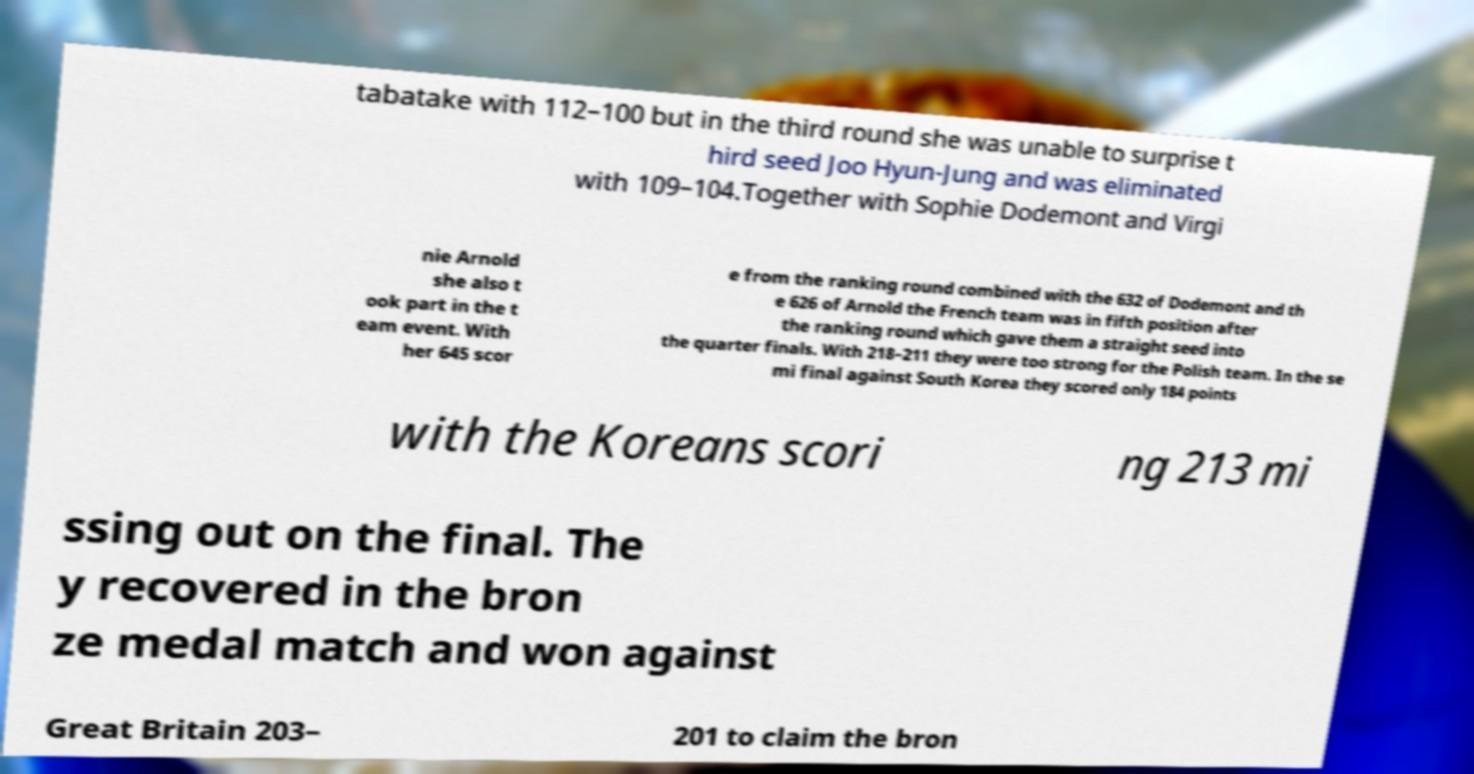Could you extract and type out the text from this image? tabatake with 112–100 but in the third round she was unable to surprise t hird seed Joo Hyun-Jung and was eliminated with 109–104.Together with Sophie Dodemont and Virgi nie Arnold she also t ook part in the t eam event. With her 645 scor e from the ranking round combined with the 632 of Dodemont and th e 626 of Arnold the French team was in fifth position after the ranking round which gave them a straight seed into the quarter finals. With 218–211 they were too strong for the Polish team. In the se mi final against South Korea they scored only 184 points with the Koreans scori ng 213 mi ssing out on the final. The y recovered in the bron ze medal match and won against Great Britain 203– 201 to claim the bron 